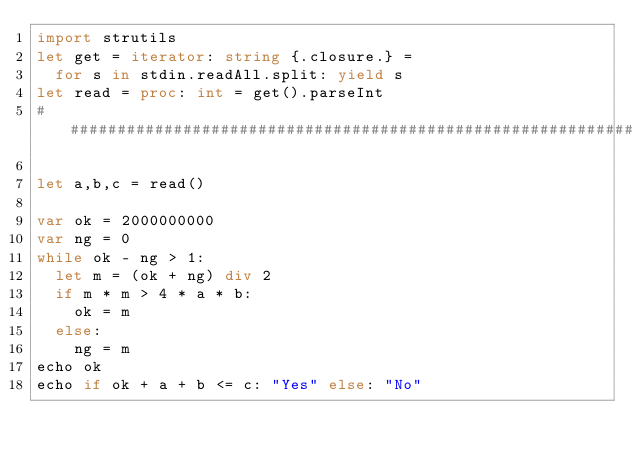Convert code to text. <code><loc_0><loc_0><loc_500><loc_500><_Nim_>import strutils
let get = iterator: string {.closure.} =
  for s in stdin.readAll.split: yield s
let read = proc: int = get().parseInt
##############################################################

let a,b,c = read()

var ok = 2000000000
var ng = 0
while ok - ng > 1:
  let m = (ok + ng) div 2
  if m * m > 4 * a * b:
    ok = m
  else:
    ng = m
echo ok
echo if ok + a + b <= c: "Yes" else: "No"</code> 